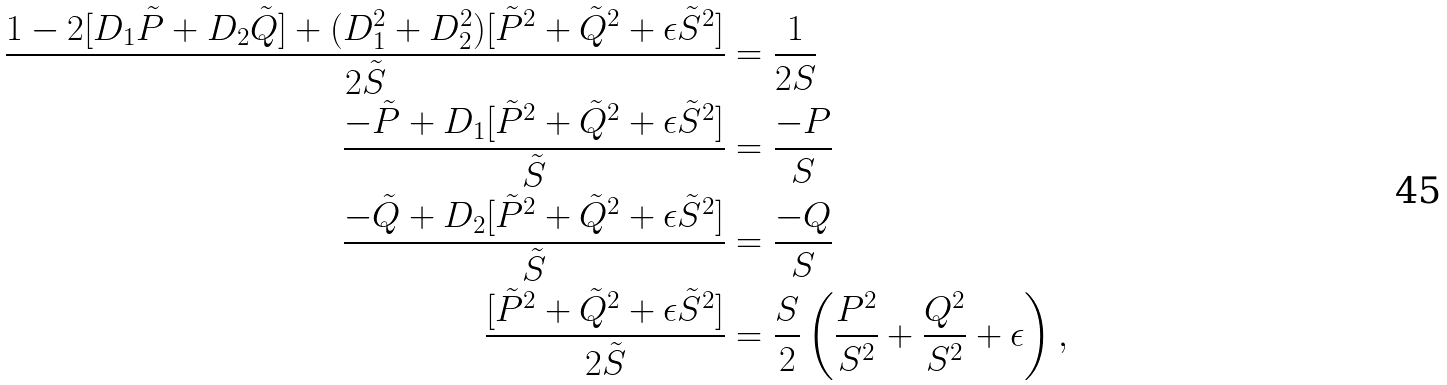Convert formula to latex. <formula><loc_0><loc_0><loc_500><loc_500>\frac { 1 - 2 [ D _ { 1 } \tilde { P } + D _ { 2 } \tilde { Q } ] + ( D _ { 1 } ^ { 2 } + D _ { 2 } ^ { 2 } ) [ \tilde { P } ^ { 2 } + \tilde { Q } ^ { 2 } + \epsilon \tilde { S } ^ { 2 } ] } { 2 \tilde { S } } & = \frac { 1 } { 2 S } \\ \frac { - \tilde { P } + D _ { 1 } [ \tilde { P } ^ { 2 } + \tilde { Q } ^ { 2 } + \epsilon \tilde { S } ^ { 2 } ] } { \tilde { S } } & = \frac { - P } { S } \\ \frac { - \tilde { Q } + D _ { 2 } [ \tilde { P } ^ { 2 } + \tilde { Q } ^ { 2 } + \epsilon \tilde { S } ^ { 2 } ] } { \tilde { S } } & = \frac { - Q } { S } \\ \frac { [ \tilde { P } ^ { 2 } + \tilde { Q } ^ { 2 } + \epsilon \tilde { S } ^ { 2 } ] } { 2 \tilde { S } } & = \frac { S } { 2 } \left ( \frac { P ^ { 2 } } { S ^ { 2 } } + \frac { Q ^ { 2 } } { S ^ { 2 } } + \epsilon \right ) ,</formula> 